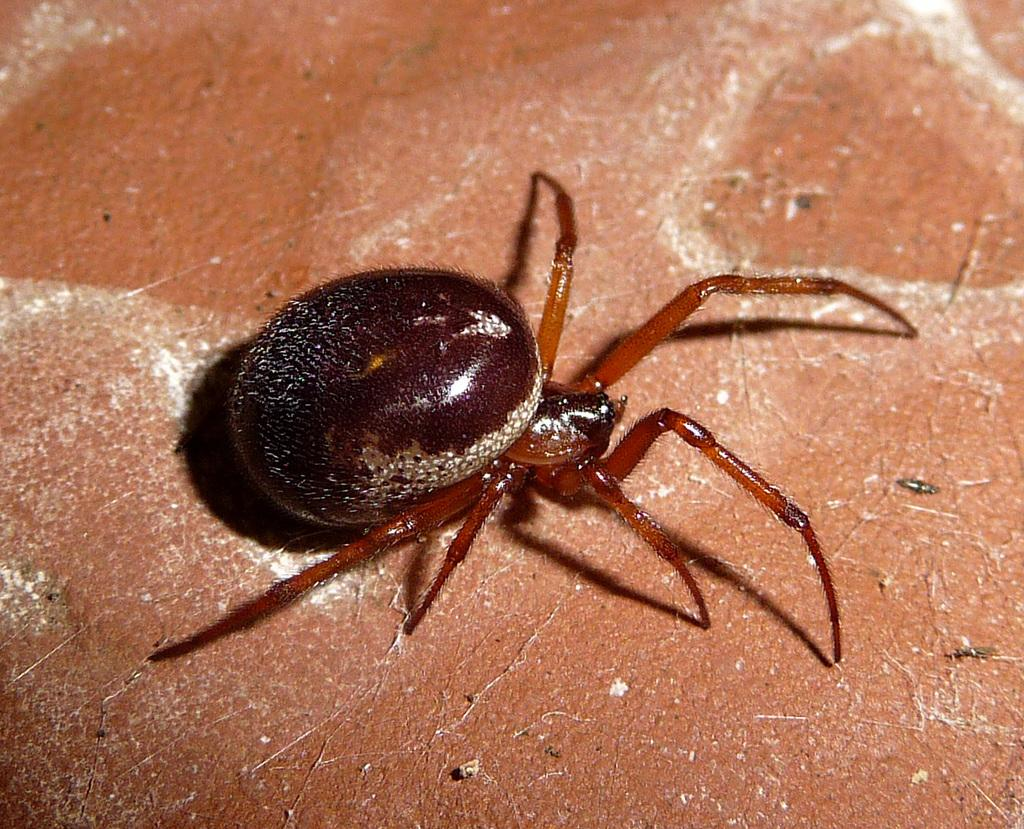What is the main subject of the image? There is a spider in the center of the image. Where is the spider located? The spider is on the wall. What type of question is being asked by the jellyfish in the image? There is no jellyfish present in the image, and therefore no such question can be asked. 